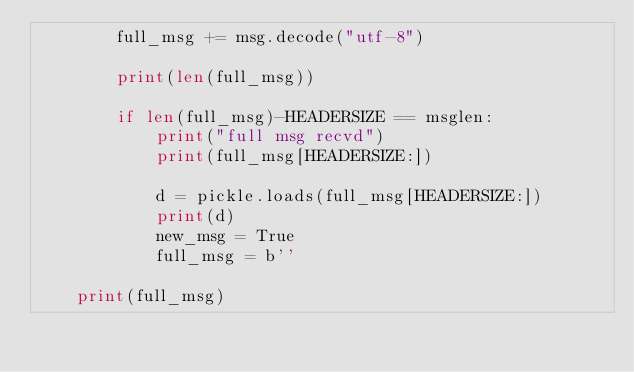Convert code to text. <code><loc_0><loc_0><loc_500><loc_500><_Python_>        full_msg += msg.decode("utf-8")

        print(len(full_msg))

        if len(full_msg)-HEADERSIZE == msglen:
            print("full msg recvd")
            print(full_msg[HEADERSIZE:])

            d = pickle.loads(full_msg[HEADERSIZE:])
            print(d)
            new_msg = True
            full_msg = b''

    print(full_msg)
</code> 